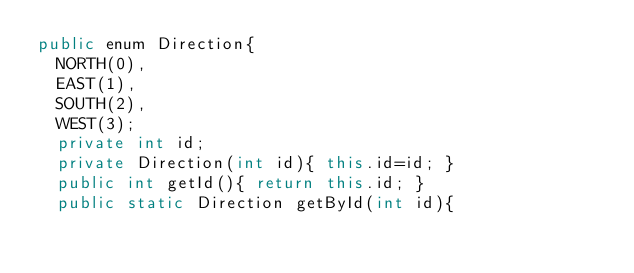<code> <loc_0><loc_0><loc_500><loc_500><_Java_>public enum Direction{
	NORTH(0),
	EAST(1),
	SOUTH(2),
	WEST(3);
	private int id;
	private Direction(int id){ this.id=id; }
	public int getId(){ return this.id; }
	public static Direction getById(int id){</code> 